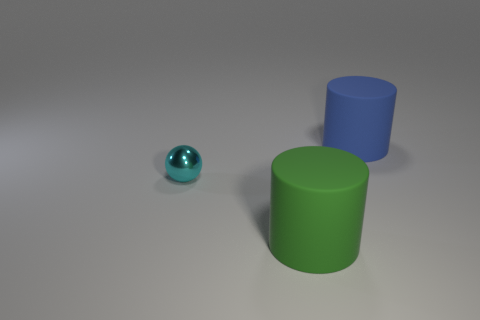Subtract 1 cylinders. How many cylinders are left? 1 Add 1 matte objects. How many objects exist? 4 Subtract all green cylinders. How many cylinders are left? 1 Subtract 0 green balls. How many objects are left? 3 Subtract all cylinders. How many objects are left? 1 Subtract all gray balls. Subtract all brown cubes. How many balls are left? 1 Subtract all brown blocks. How many red spheres are left? 0 Subtract all big matte objects. Subtract all blue cylinders. How many objects are left? 0 Add 2 green things. How many green things are left? 3 Add 2 large gray rubber things. How many large gray rubber things exist? 2 